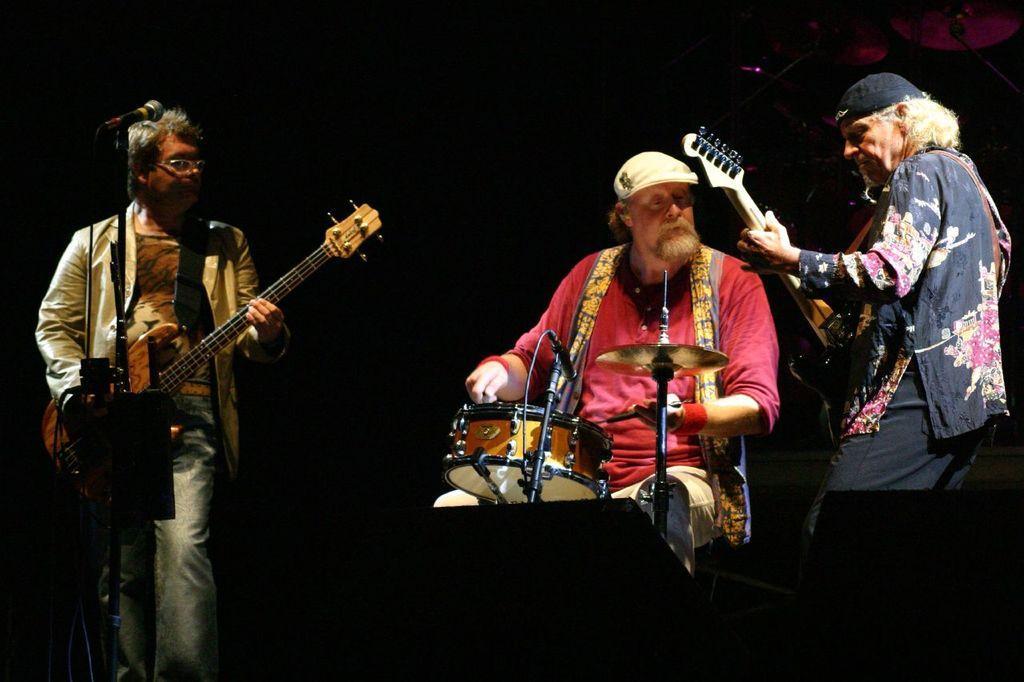Please provide a concise description of this image. In this picture we can see three men where two are holding guitars in their hands and playing it and in middle man playing drums and in front of them we have a mic and in the background it is dark. 